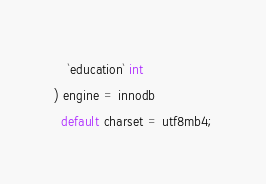<code> <loc_0><loc_0><loc_500><loc_500><_SQL_>    `education` int
) engine = innodb
  default charset = utf8mb4;</code> 